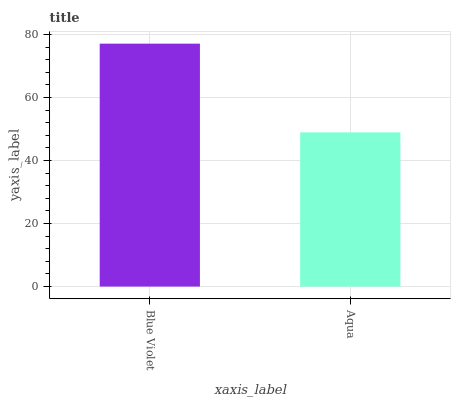Is Aqua the minimum?
Answer yes or no. Yes. Is Blue Violet the maximum?
Answer yes or no. Yes. Is Aqua the maximum?
Answer yes or no. No. Is Blue Violet greater than Aqua?
Answer yes or no. Yes. Is Aqua less than Blue Violet?
Answer yes or no. Yes. Is Aqua greater than Blue Violet?
Answer yes or no. No. Is Blue Violet less than Aqua?
Answer yes or no. No. Is Blue Violet the high median?
Answer yes or no. Yes. Is Aqua the low median?
Answer yes or no. Yes. Is Aqua the high median?
Answer yes or no. No. Is Blue Violet the low median?
Answer yes or no. No. 